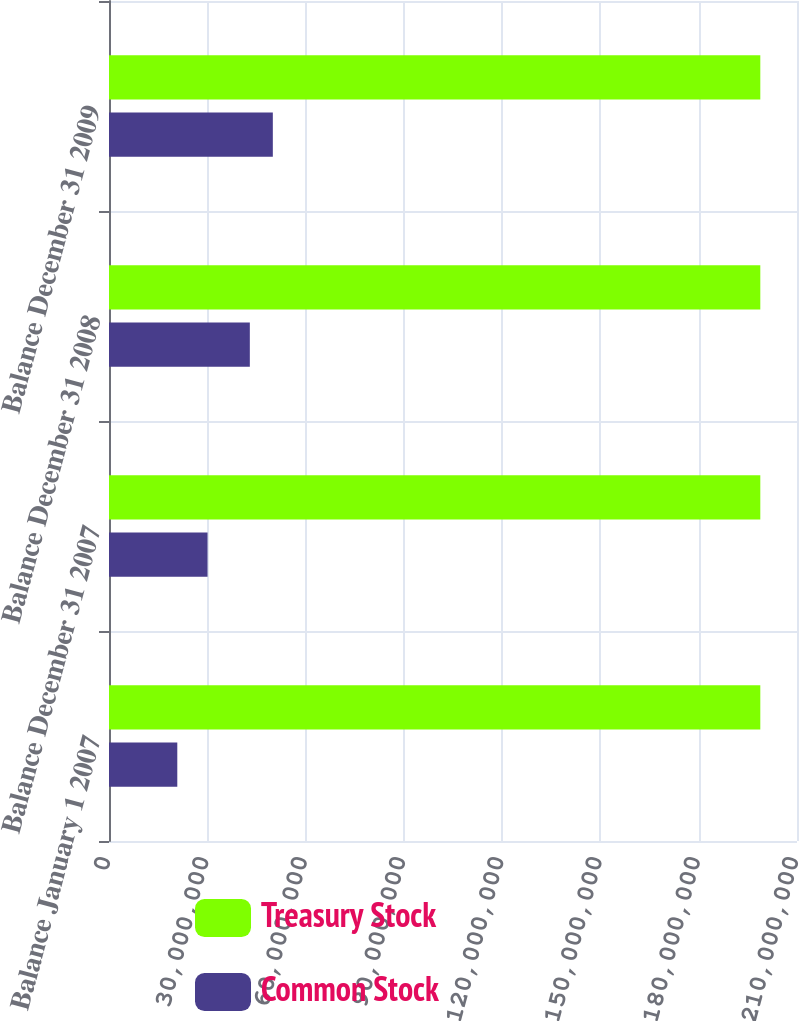<chart> <loc_0><loc_0><loc_500><loc_500><stacked_bar_chart><ecel><fcel>Balance January 1 2007<fcel>Balance December 31 2007<fcel>Balance December 31 2008<fcel>Balance December 31 2009<nl><fcel>Treasury Stock<fcel>1.988e+08<fcel>1.988e+08<fcel>1.988e+08<fcel>1.988e+08<nl><fcel>Common Stock<fcel>2.08457e+07<fcel>3.00741e+07<fcel>4.29856e+07<fcel>5.00059e+07<nl></chart> 